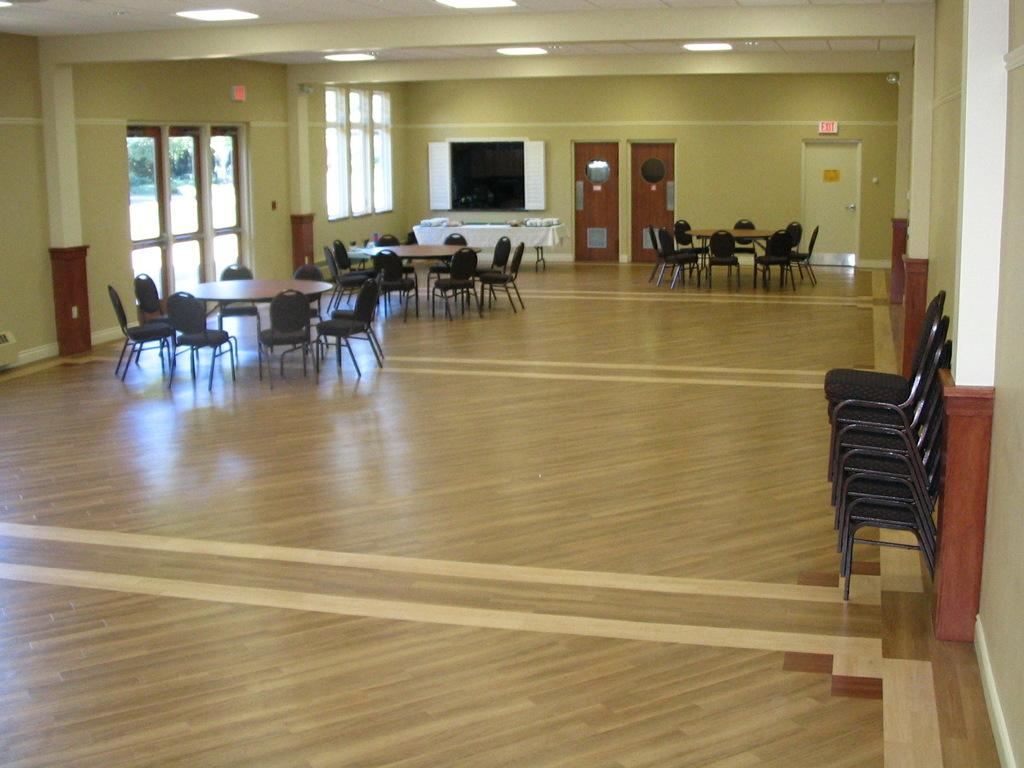Where was the image taken? The image was taken inside a room. What furniture is present in the room? There are chairs and tables in the room. What type of lighting is present in the room? There are lights at the top of the room. How can one enter or exit the room? There is a door on the right side of the room. What type of sail can be seen in the image? There is no sail present in the image; it was taken inside a room with chairs, tables, lights, and a door. 